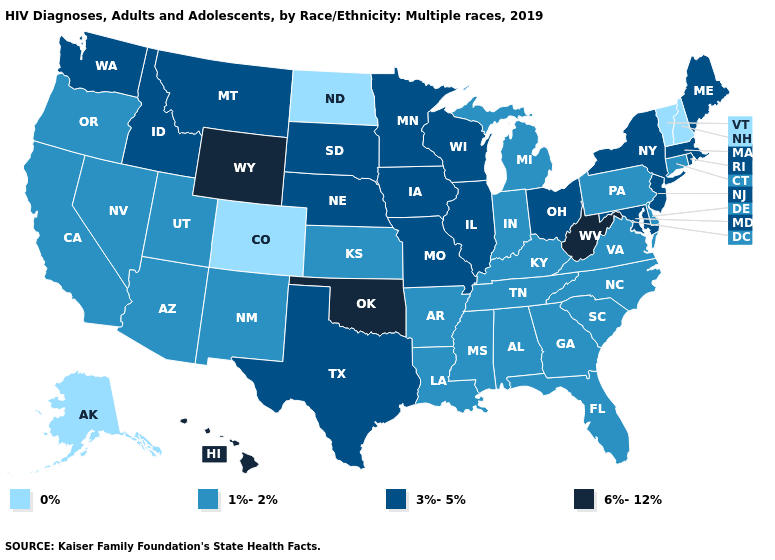Does South Carolina have the same value as Mississippi?
Keep it brief. Yes. Which states have the lowest value in the South?
Short answer required. Alabama, Arkansas, Delaware, Florida, Georgia, Kentucky, Louisiana, Mississippi, North Carolina, South Carolina, Tennessee, Virginia. Name the states that have a value in the range 0%?
Keep it brief. Alaska, Colorado, New Hampshire, North Dakota, Vermont. Name the states that have a value in the range 3%-5%?
Short answer required. Idaho, Illinois, Iowa, Maine, Maryland, Massachusetts, Minnesota, Missouri, Montana, Nebraska, New Jersey, New York, Ohio, Rhode Island, South Dakota, Texas, Washington, Wisconsin. Does Vermont have a higher value than West Virginia?
Concise answer only. No. Does Oklahoma have the highest value in the South?
Answer briefly. Yes. Does Connecticut have the highest value in the USA?
Short answer required. No. Name the states that have a value in the range 1%-2%?
Quick response, please. Alabama, Arizona, Arkansas, California, Connecticut, Delaware, Florida, Georgia, Indiana, Kansas, Kentucky, Louisiana, Michigan, Mississippi, Nevada, New Mexico, North Carolina, Oregon, Pennsylvania, South Carolina, Tennessee, Utah, Virginia. Name the states that have a value in the range 1%-2%?
Write a very short answer. Alabama, Arizona, Arkansas, California, Connecticut, Delaware, Florida, Georgia, Indiana, Kansas, Kentucky, Louisiana, Michigan, Mississippi, Nevada, New Mexico, North Carolina, Oregon, Pennsylvania, South Carolina, Tennessee, Utah, Virginia. Name the states that have a value in the range 1%-2%?
Be succinct. Alabama, Arizona, Arkansas, California, Connecticut, Delaware, Florida, Georgia, Indiana, Kansas, Kentucky, Louisiana, Michigan, Mississippi, Nevada, New Mexico, North Carolina, Oregon, Pennsylvania, South Carolina, Tennessee, Utah, Virginia. What is the lowest value in states that border Tennessee?
Answer briefly. 1%-2%. Does Utah have the lowest value in the West?
Quick response, please. No. What is the lowest value in states that border Rhode Island?
Concise answer only. 1%-2%. Name the states that have a value in the range 6%-12%?
Answer briefly. Hawaii, Oklahoma, West Virginia, Wyoming. What is the value of Virginia?
Answer briefly. 1%-2%. 